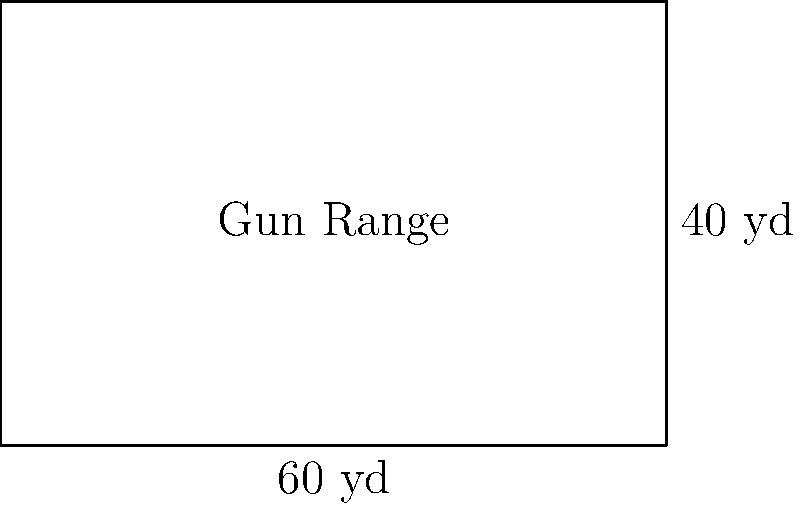A local shooting club plans to construct a rectangular gun range. The range measures 60 yards in length and 40 yards in width. To ensure safety, they need to install a fence around the entire perimeter. How many yards of fencing will be required to completely enclose the gun range? To find the perimeter of the rectangular gun range, we need to add up the lengths of all four sides. Let's break it down step-by-step:

1. Identify the dimensions:
   Length (L) = 60 yards
   Width (W) = 40 yards

2. The formula for the perimeter of a rectangle is:
   $$P = 2L + 2W$$

3. Substitute the values:
   $$P = 2(60) + 2(40)$$

4. Calculate:
   $$P = 120 + 80 = 200$$

Therefore, the perimeter of the gun range is 200 yards. This is the amount of fencing required to enclose the entire range.
Answer: 200 yards 